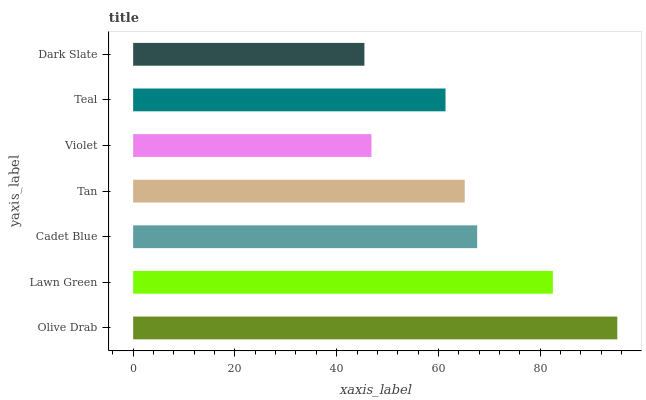Is Dark Slate the minimum?
Answer yes or no. Yes. Is Olive Drab the maximum?
Answer yes or no. Yes. Is Lawn Green the minimum?
Answer yes or no. No. Is Lawn Green the maximum?
Answer yes or no. No. Is Olive Drab greater than Lawn Green?
Answer yes or no. Yes. Is Lawn Green less than Olive Drab?
Answer yes or no. Yes. Is Lawn Green greater than Olive Drab?
Answer yes or no. No. Is Olive Drab less than Lawn Green?
Answer yes or no. No. Is Tan the high median?
Answer yes or no. Yes. Is Tan the low median?
Answer yes or no. Yes. Is Violet the high median?
Answer yes or no. No. Is Dark Slate the low median?
Answer yes or no. No. 